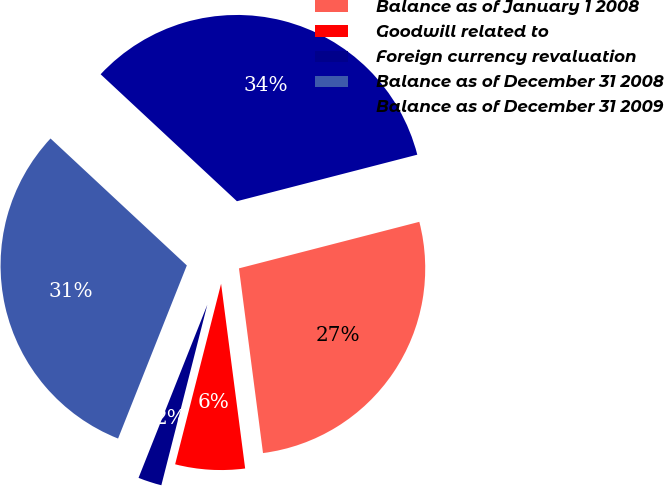<chart> <loc_0><loc_0><loc_500><loc_500><pie_chart><fcel>Balance as of January 1 2008<fcel>Goodwill related to<fcel>Foreign currency revaluation<fcel>Balance as of December 31 2008<fcel>Balance as of December 31 2009<nl><fcel>26.96%<fcel>6.03%<fcel>2.05%<fcel>30.92%<fcel>34.05%<nl></chart> 